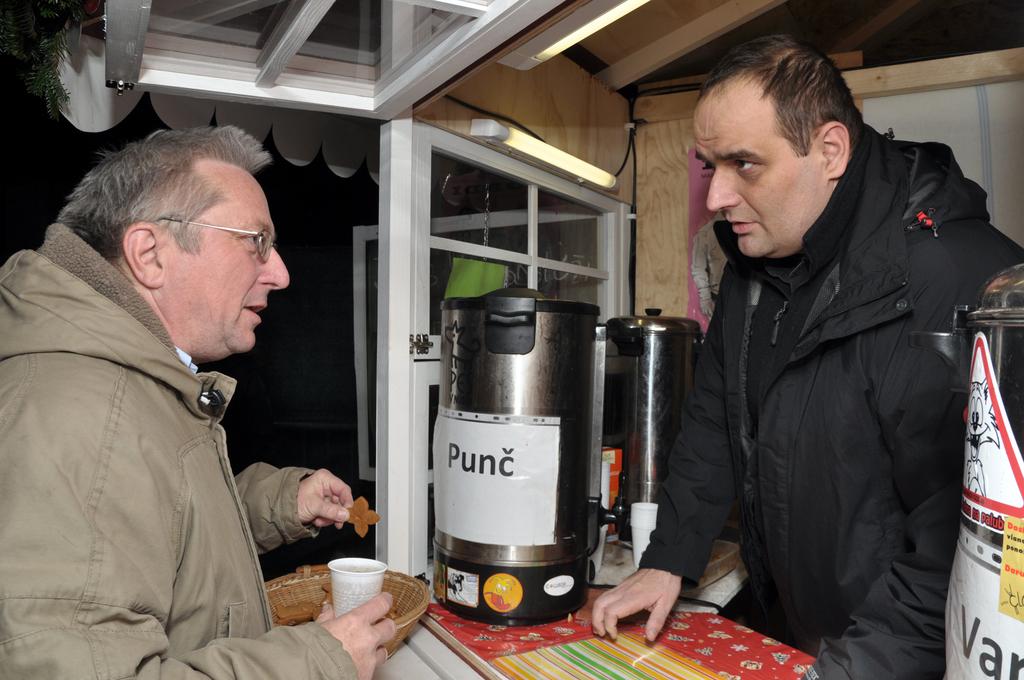What kind of coffee?
Keep it short and to the point. Punc. What is the label on the container?
Offer a very short reply. Punc. 